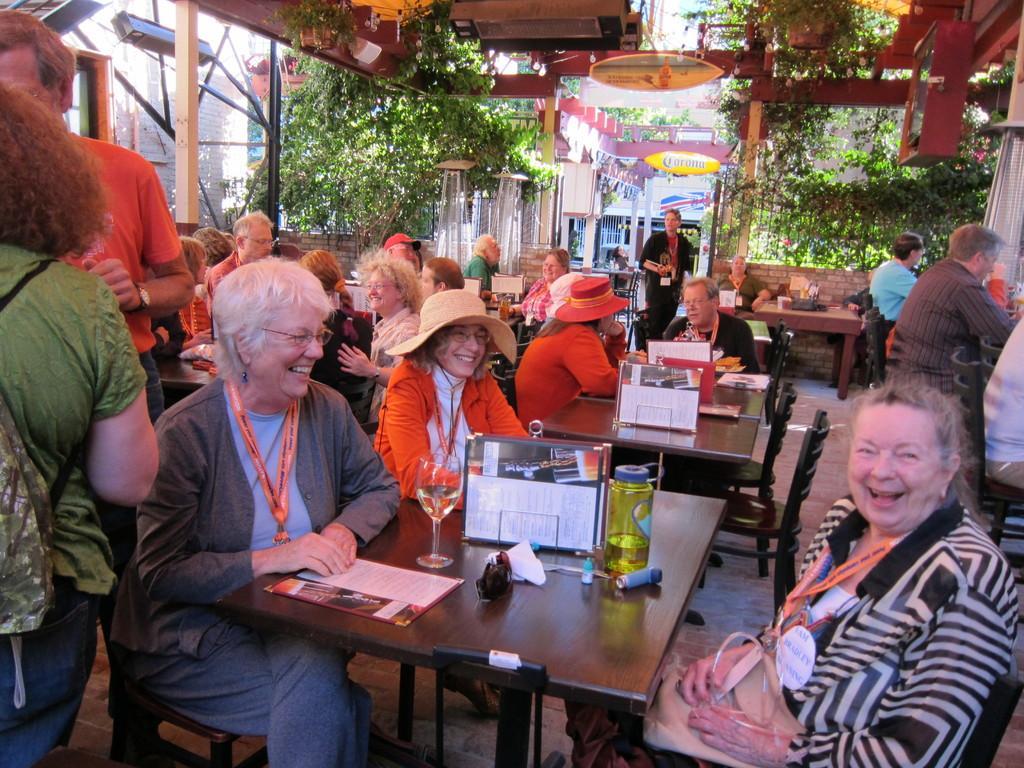Describe this image in one or two sentences. In this picture a group of people sitting, there is a woman staring at the person and laughing. There are plants in the background. 